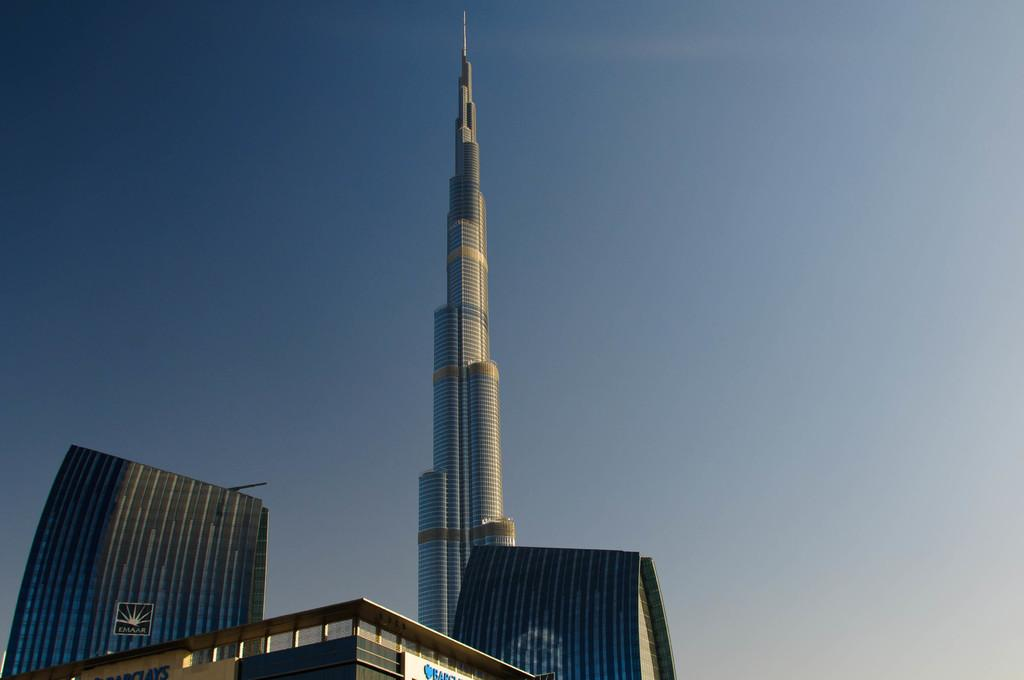What type of structures are present in the image? There are buildings and a tower in the image. What else can be seen in the image besides the structures? There is a board in the image. What is visible in the background of the image? The sky is visible in the image. Can you determine the time of day the image was taken? The image was likely taken during the day, as the sky is visible and there is no indication of darkness. Can you tell me what date is written on the calendar in the image? There is no calendar present in the image, so it is not possible to determine the date. 